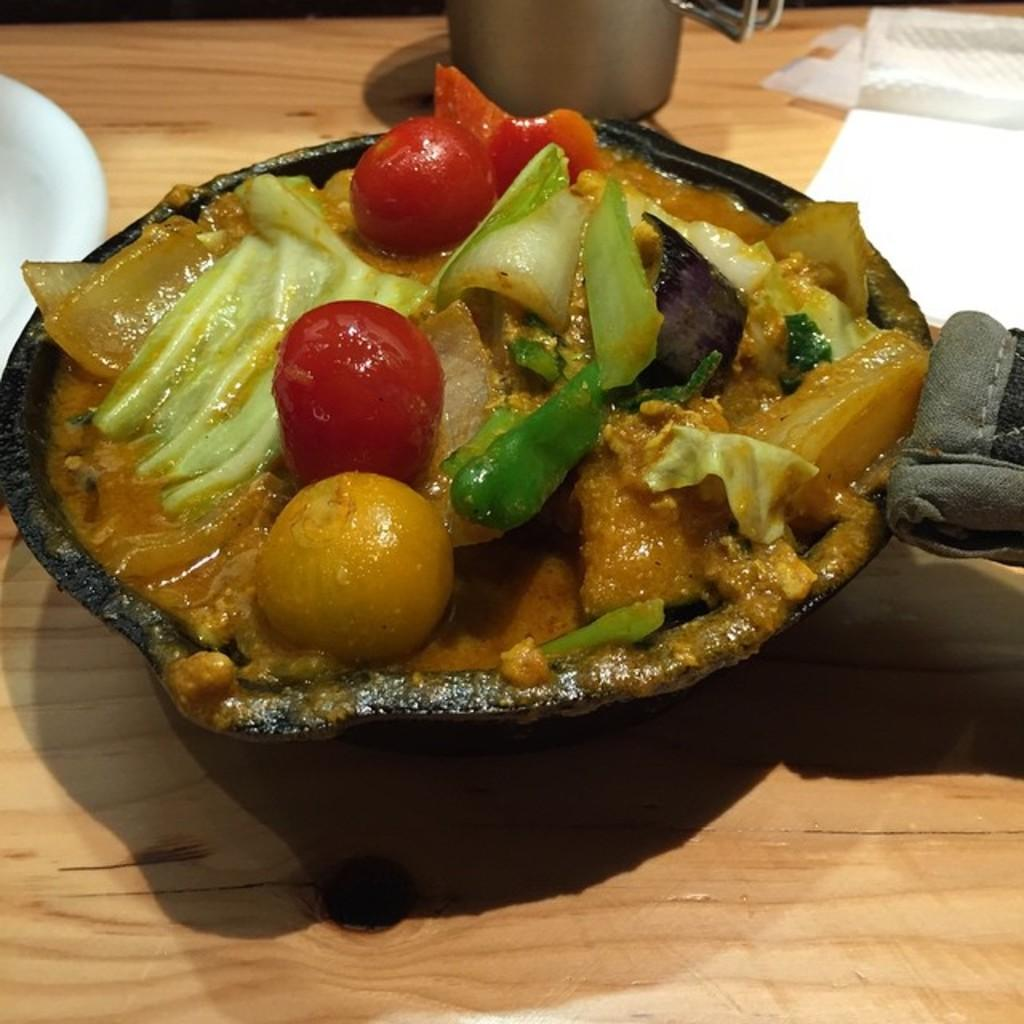What type of container is holding the food in the image? There is food in a black container in the image. What else can be seen in the image besides the food and container? Tissue papers are present in the image. What type of flag is being waved by the honey in the image? There is no flag or honey present in the image. 